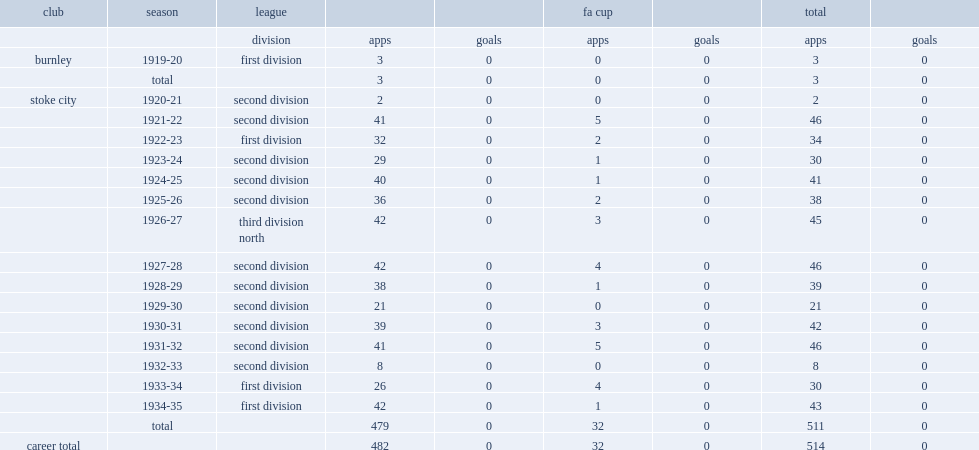How many appearances did bob mcgrory spend 15 seasons as a player for stoke failed to score a single goal? 511.0. Write the full table. {'header': ['club', 'season', 'league', '', '', 'fa cup', '', 'total', ''], 'rows': [['', '', 'division', 'apps', 'goals', 'apps', 'goals', 'apps', 'goals'], ['burnley', '1919-20', 'first division', '3', '0', '0', '0', '3', '0'], ['', 'total', '', '3', '0', '0', '0', '3', '0'], ['stoke city', '1920-21', 'second division', '2', '0', '0', '0', '2', '0'], ['', '1921-22', 'second division', '41', '0', '5', '0', '46', '0'], ['', '1922-23', 'first division', '32', '0', '2', '0', '34', '0'], ['', '1923-24', 'second division', '29', '0', '1', '0', '30', '0'], ['', '1924-25', 'second division', '40', '0', '1', '0', '41', '0'], ['', '1925-26', 'second division', '36', '0', '2', '0', '38', '0'], ['', '1926-27', 'third division north', '42', '0', '3', '0', '45', '0'], ['', '1927-28', 'second division', '42', '0', '4', '0', '46', '0'], ['', '1928-29', 'second division', '38', '0', '1', '0', '39', '0'], ['', '1929-30', 'second division', '21', '0', '0', '0', '21', '0'], ['', '1930-31', 'second division', '39', '0', '3', '0', '42', '0'], ['', '1931-32', 'second division', '41', '0', '5', '0', '46', '0'], ['', '1932-33', 'second division', '8', '0', '0', '0', '8', '0'], ['', '1933-34', 'first division', '26', '0', '4', '0', '30', '0'], ['', '1934-35', 'first division', '42', '0', '1', '0', '43', '0'], ['', 'total', '', '479', '0', '32', '0', '511', '0'], ['career total', '', '', '482', '0', '32', '0', '514', '0']]} 